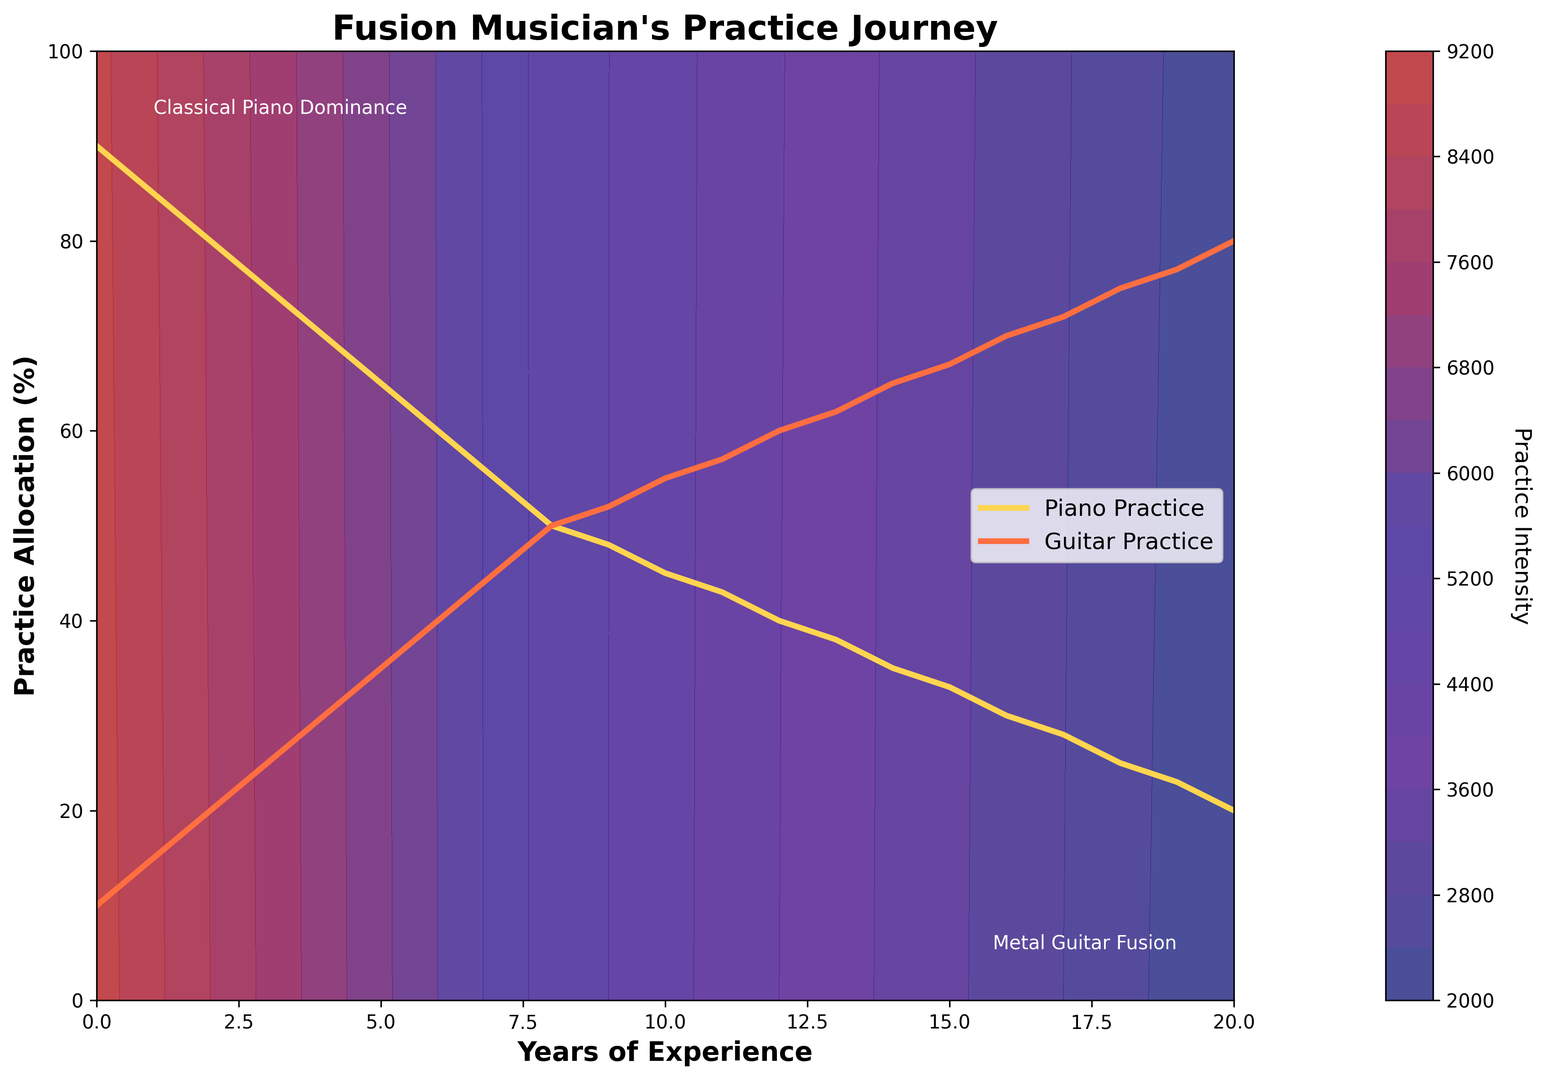What happens to the allocation of practice time between piano and guitar techniques as the musician gains more years of experience? Initially, the musician allocates more practice time to the piano. Over the years, this shifts towards more guitar practice. This is evident from the decreasing percentage of piano practice and the increasing percentage of guitar practice.
Answer: Shift from piano to guitar After how many years does the percentage of guitar practice surpass that of piano practice? By visually inspecting the plot, it appears that the guitar practice surpasses piano practice around 9 years of experience as the two lines cross each other at this point on the x-axis.
Answer: 9 years What is the trend in piano practice allocation after 10 years of experience? From the plot, we can see that after 10 years, the piano practice allocation continues to decrease gradually. This is shown by the downward slope of the yellow line representing piano practice.
Answer: Decreasing If you check the contour colors, which periods seem to have the highest practice intensity, and how does this relate to piano and guitar practice? The regions with the deepest color indicate higher practice intensity. The dark colors are more prevalent at the start of the graph, between 0 to 5 years of experience, suggesting higher practice intensity early on when piano practice is dominant.
Answer: Early years What is the approximate difference in practice time allocation between the piano and the guitar after 15 years of experience? At 15 years of experience, the piano practice allocation is around 33%, and the guitar practice allocation is about 67%. The difference is approximately 67% - 33% = 34%.
Answer: 34% Between which years is the practice allocation most balanced between piano and guitar techniques? The practice allocation is most balanced when the percentages of piano and guitar practice are closest to each other. This occurs around 8 years of experience where both practices are about 50%.
Answer: 8 years What visual changes in the contour map indicate a shift in focus from piano to guitar practice? The color transition on the contour map from darker (near the y-axis showing higher piano practice intensity) to lighter shades towards the right side of the graph indicates a shift in focus from piano to guitar practice over the years.
Answer: Color transition Around how many years does the practice allocation for guitar reach 75%? By checking the plotted data, the guitar practice allocation reaches 75% around 18 years of experience. This is visible from the point where the red line representing guitar practice touches the 75% mark on the y-axis.
Answer: 18 years How does the practice allocation change between years 5 and 10? During years 5 to 10, piano practice decreases from 65% to 45%, and guitar practice increases from 35% to 55%. This change is seen by the declining yellow line for piano and the ascending red line for guitar.
Answer: Piano decreases, guitar increases 